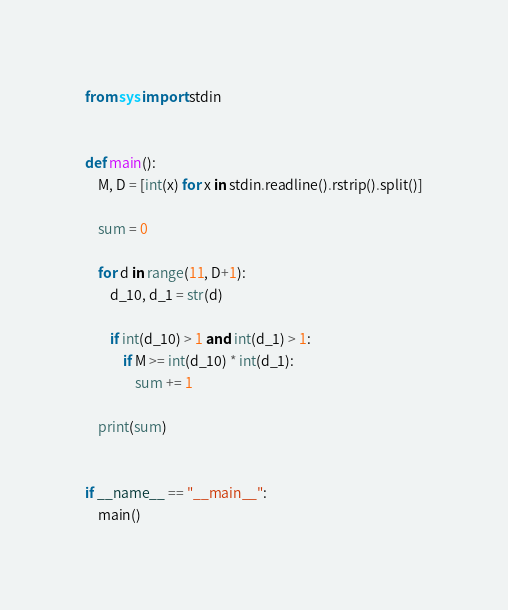<code> <loc_0><loc_0><loc_500><loc_500><_Python_>from sys import stdin


def main():
    M, D = [int(x) for x in stdin.readline().rstrip().split()]

    sum = 0

    for d in range(11, D+1):
        d_10, d_1 = str(d)

        if int(d_10) > 1 and int(d_1) > 1:
            if M >= int(d_10) * int(d_1):
                sum += 1

    print(sum)


if __name__ == "__main__":
    main()
</code> 